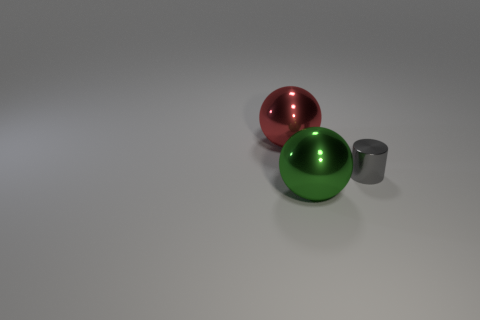Add 3 big metal balls. How many objects exist? 6 Subtract all spheres. How many objects are left? 1 Subtract all red things. Subtract all gray shiny cylinders. How many objects are left? 1 Add 3 large red metallic objects. How many large red metallic objects are left? 4 Add 3 small red rubber cylinders. How many small red rubber cylinders exist? 3 Subtract 0 cyan balls. How many objects are left? 3 